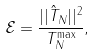<formula> <loc_0><loc_0><loc_500><loc_500>\mathcal { E } = \frac { | | \hat { T } _ { N } | | ^ { 2 } } { T _ { N } ^ { \max } } ,</formula> 